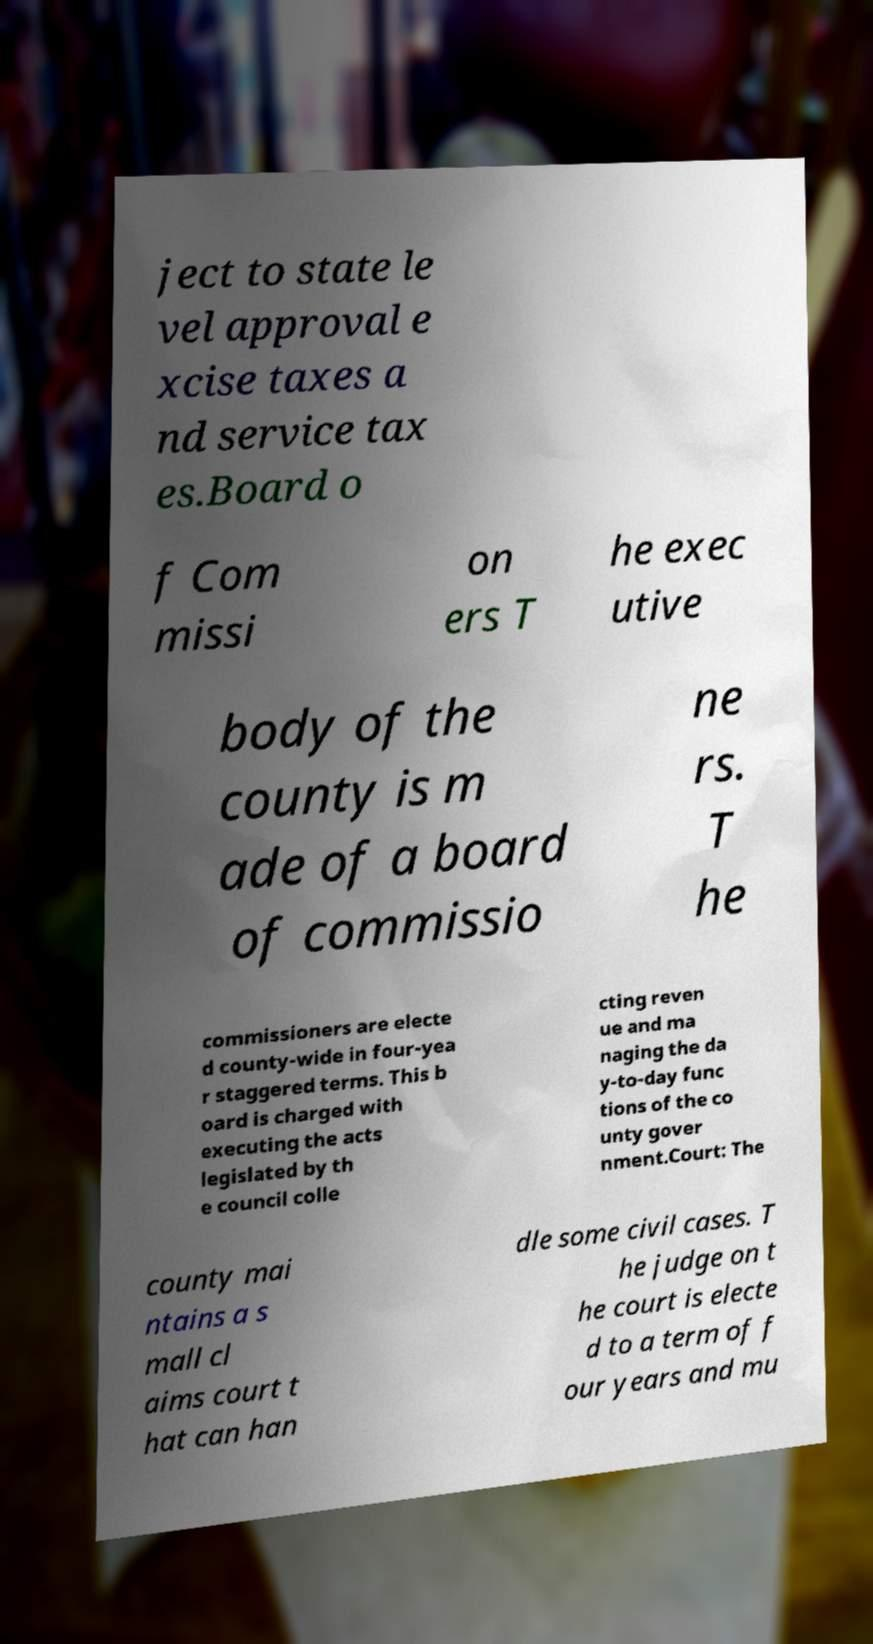Can you accurately transcribe the text from the provided image for me? ject to state le vel approval e xcise taxes a nd service tax es.Board o f Com missi on ers T he exec utive body of the county is m ade of a board of commissio ne rs. T he commissioners are electe d county-wide in four-yea r staggered terms. This b oard is charged with executing the acts legislated by th e council colle cting reven ue and ma naging the da y-to-day func tions of the co unty gover nment.Court: The county mai ntains a s mall cl aims court t hat can han dle some civil cases. T he judge on t he court is electe d to a term of f our years and mu 